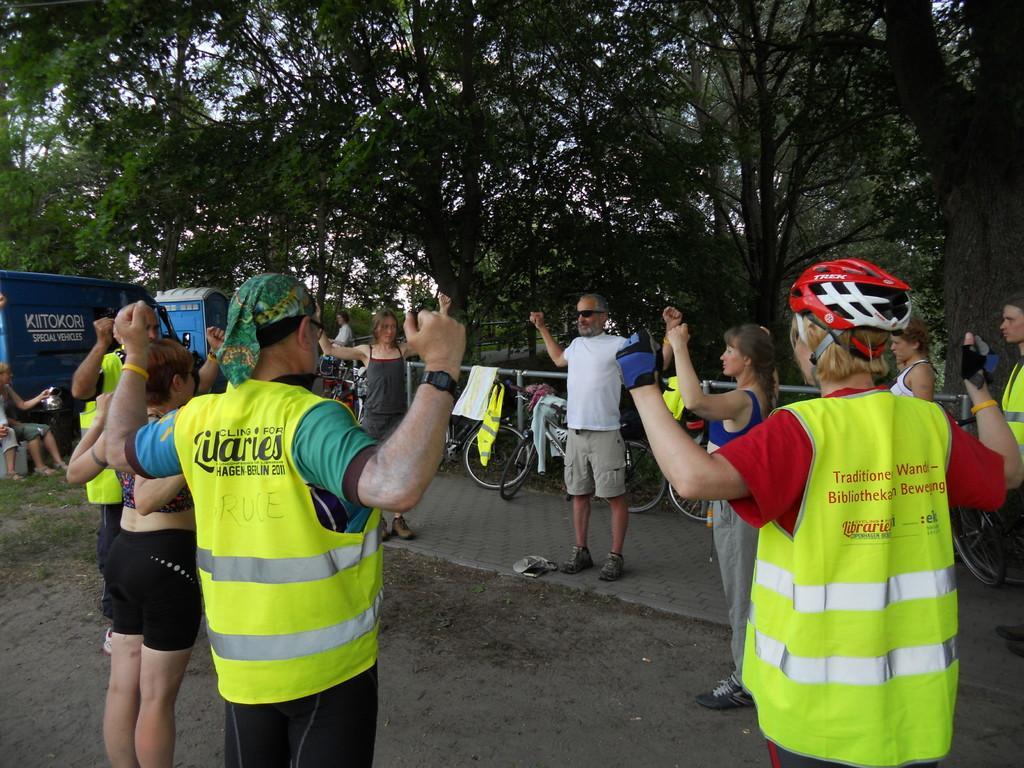In one or two sentences, can you explain what this image depicts? In this picture we can see a group of people doing some exercise and in background we can see some people are sitting and here we have vehicle, trees, fence, bicycles parked on a footpath. 